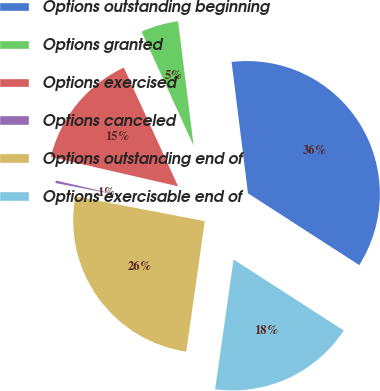Convert chart to OTSL. <chart><loc_0><loc_0><loc_500><loc_500><pie_chart><fcel>Options outstanding beginning<fcel>Options granted<fcel>Options exercised<fcel>Options canceled<fcel>Options outstanding end of<fcel>Options exercisable end of<nl><fcel>36.1%<fcel>4.84%<fcel>14.57%<fcel>0.59%<fcel>25.77%<fcel>18.12%<nl></chart> 